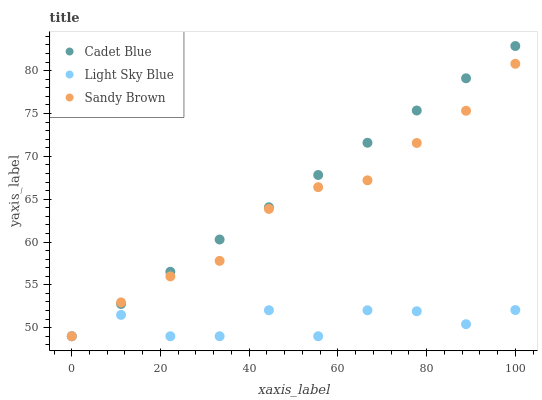Does Light Sky Blue have the minimum area under the curve?
Answer yes or no. Yes. Does Cadet Blue have the maximum area under the curve?
Answer yes or no. Yes. Does Sandy Brown have the minimum area under the curve?
Answer yes or no. No. Does Sandy Brown have the maximum area under the curve?
Answer yes or no. No. Is Cadet Blue the smoothest?
Answer yes or no. Yes. Is Light Sky Blue the roughest?
Answer yes or no. Yes. Is Sandy Brown the smoothest?
Answer yes or no. No. Is Sandy Brown the roughest?
Answer yes or no. No. Does Cadet Blue have the lowest value?
Answer yes or no. Yes. Does Cadet Blue have the highest value?
Answer yes or no. Yes. Does Sandy Brown have the highest value?
Answer yes or no. No. Does Light Sky Blue intersect Sandy Brown?
Answer yes or no. Yes. Is Light Sky Blue less than Sandy Brown?
Answer yes or no. No. Is Light Sky Blue greater than Sandy Brown?
Answer yes or no. No. 